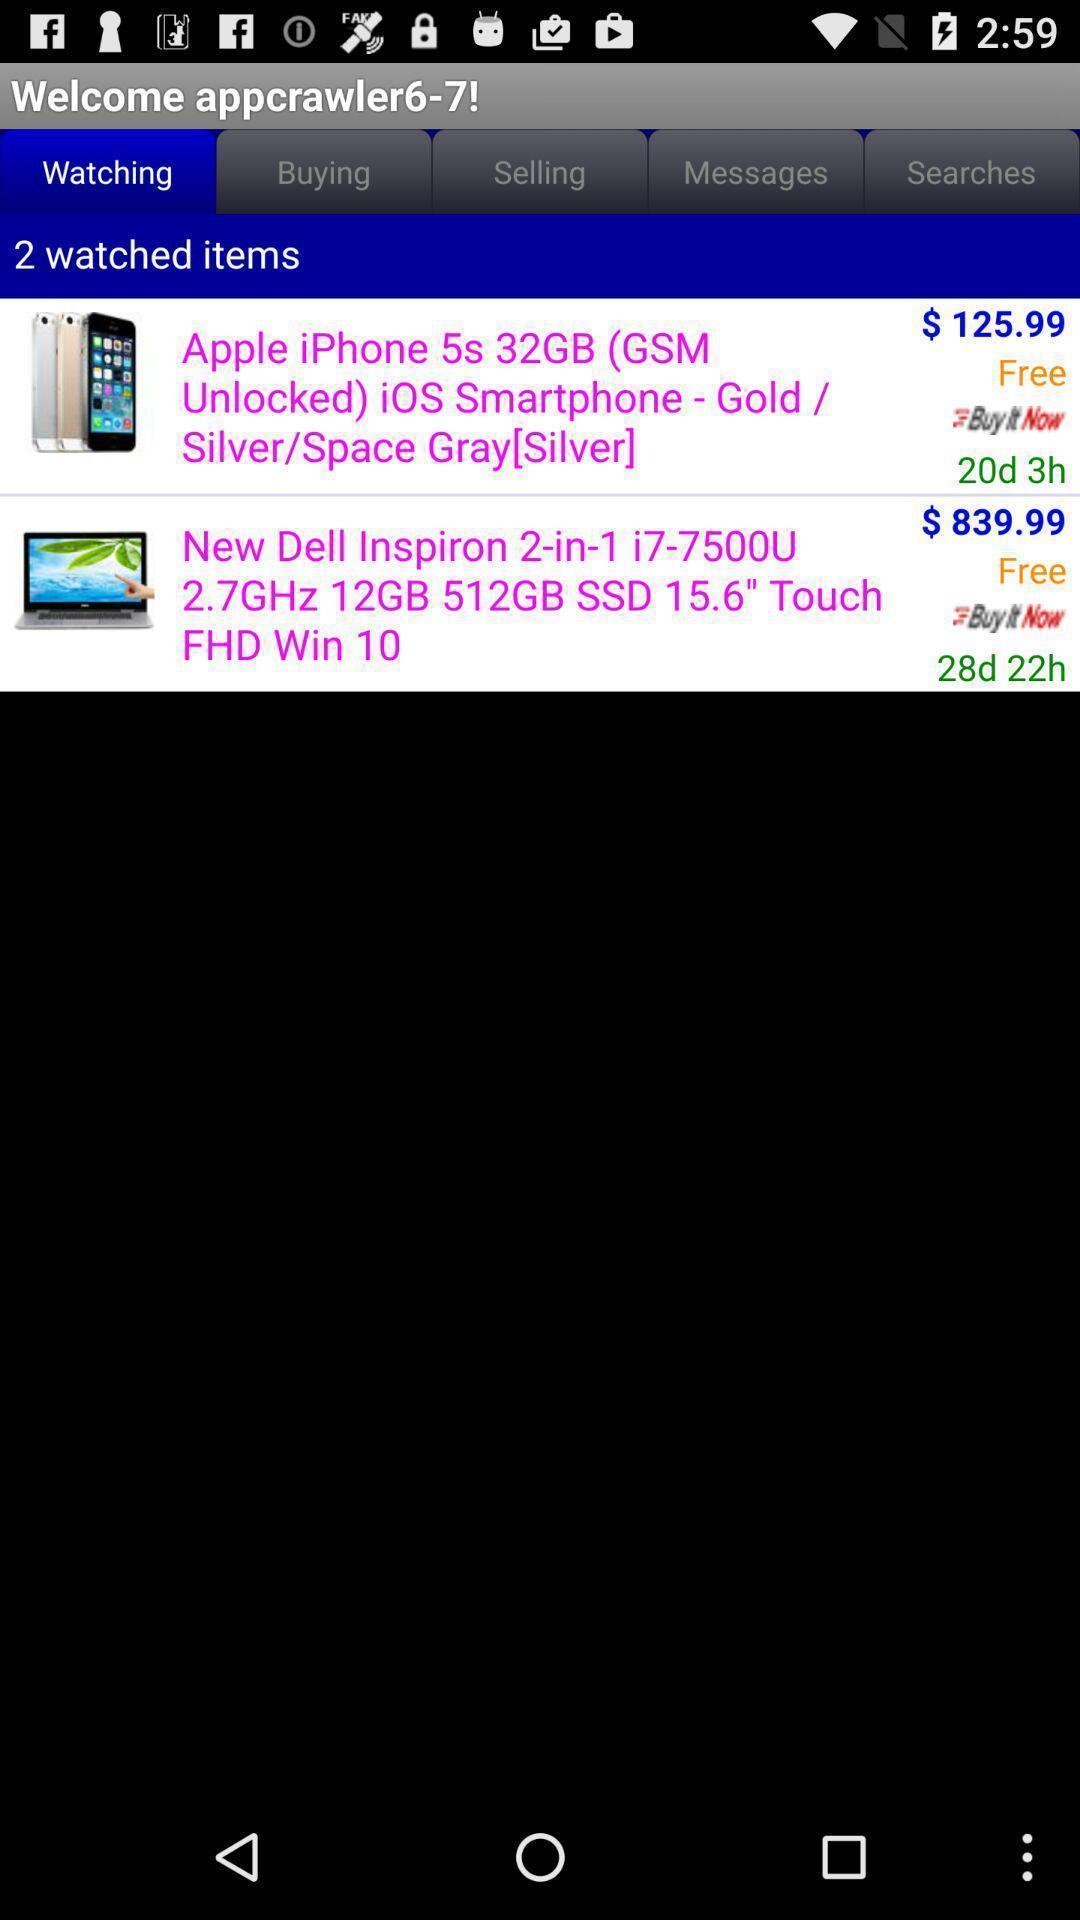What can you discern from this picture? Two articles of an e-commerce app. 